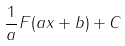Convert formula to latex. <formula><loc_0><loc_0><loc_500><loc_500>\frac { 1 } { a } F ( a x + b ) + C</formula> 